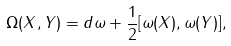<formula> <loc_0><loc_0><loc_500><loc_500>\Omega ( X , Y ) = d \omega + \frac { 1 } { 2 } [ \omega ( X ) , \omega ( Y ) ] ,</formula> 